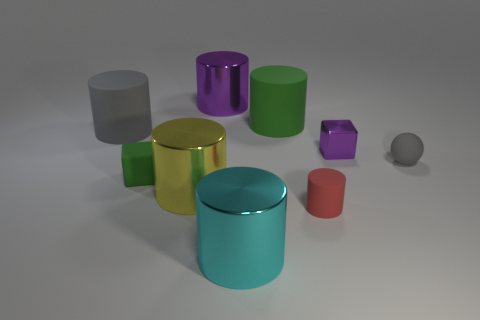Subtract all yellow cylinders. How many cylinders are left? 5 Subtract all large purple cylinders. How many cylinders are left? 5 Subtract 3 cylinders. How many cylinders are left? 3 Subtract all purple cylinders. Subtract all green balls. How many cylinders are left? 5 Add 1 small purple things. How many objects exist? 10 Subtract all cubes. How many objects are left? 7 Subtract all tiny brown shiny balls. Subtract all tiny red matte objects. How many objects are left? 8 Add 7 tiny gray rubber things. How many tiny gray rubber things are left? 8 Add 9 large cyan objects. How many large cyan objects exist? 10 Subtract 0 blue cylinders. How many objects are left? 9 